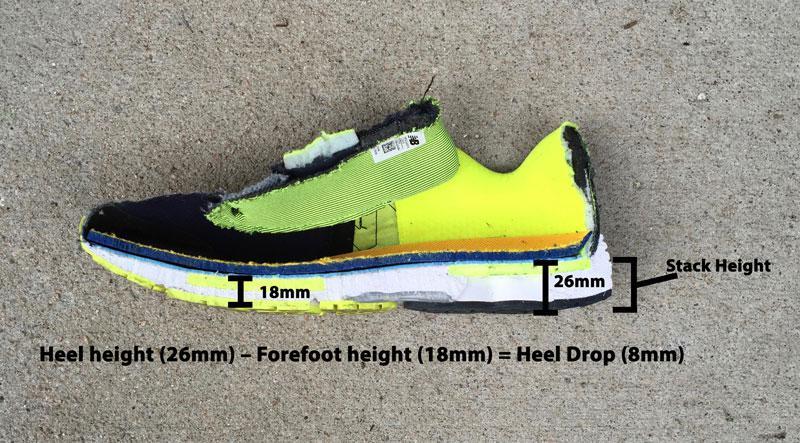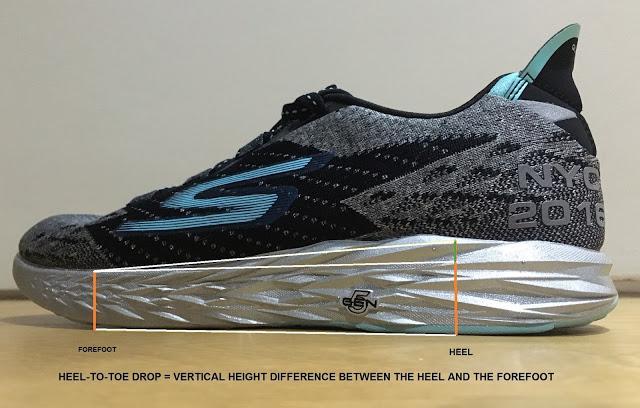The first image is the image on the left, the second image is the image on the right. Given the left and right images, does the statement "There are more than two shoes pictured." hold true? Answer yes or no. No. The first image is the image on the left, the second image is the image on the right. Examine the images to the left and right. Is the description "The left image contains a matched pair of unworn sneakers, and the right image features a sneaker that shares some of the color of the lefthand sneaker." accurate? Answer yes or no. No. 